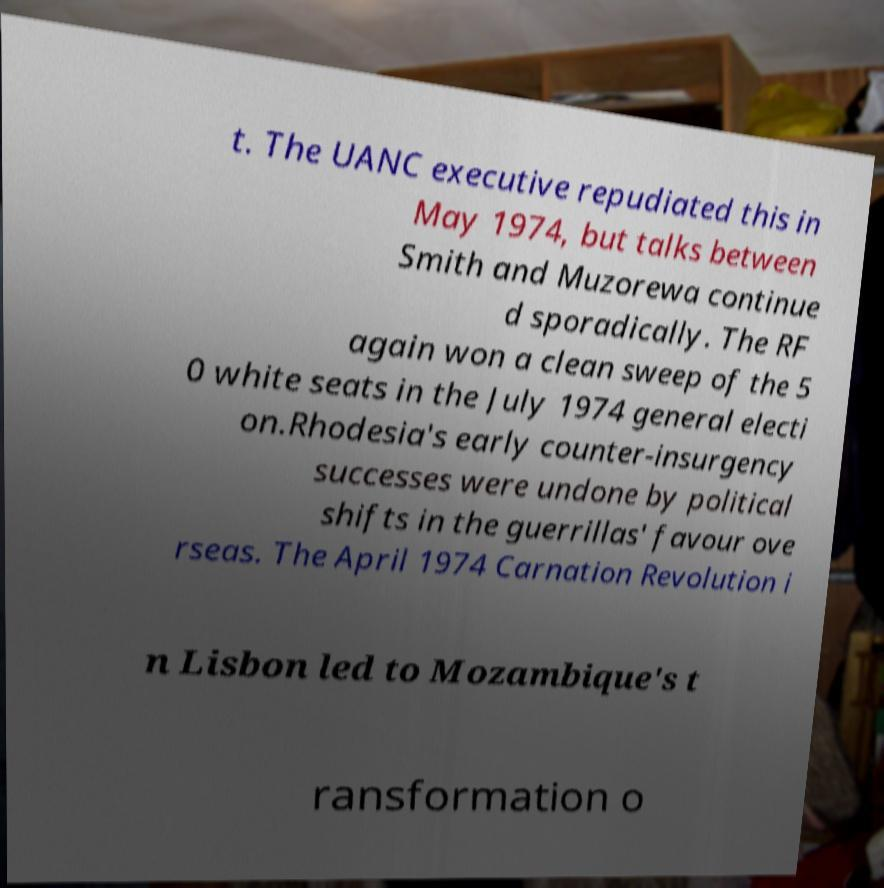I need the written content from this picture converted into text. Can you do that? t. The UANC executive repudiated this in May 1974, but talks between Smith and Muzorewa continue d sporadically. The RF again won a clean sweep of the 5 0 white seats in the July 1974 general electi on.Rhodesia's early counter-insurgency successes were undone by political shifts in the guerrillas' favour ove rseas. The April 1974 Carnation Revolution i n Lisbon led to Mozambique's t ransformation o 